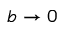Convert formula to latex. <formula><loc_0><loc_0><loc_500><loc_500>b \rightarrow 0</formula> 